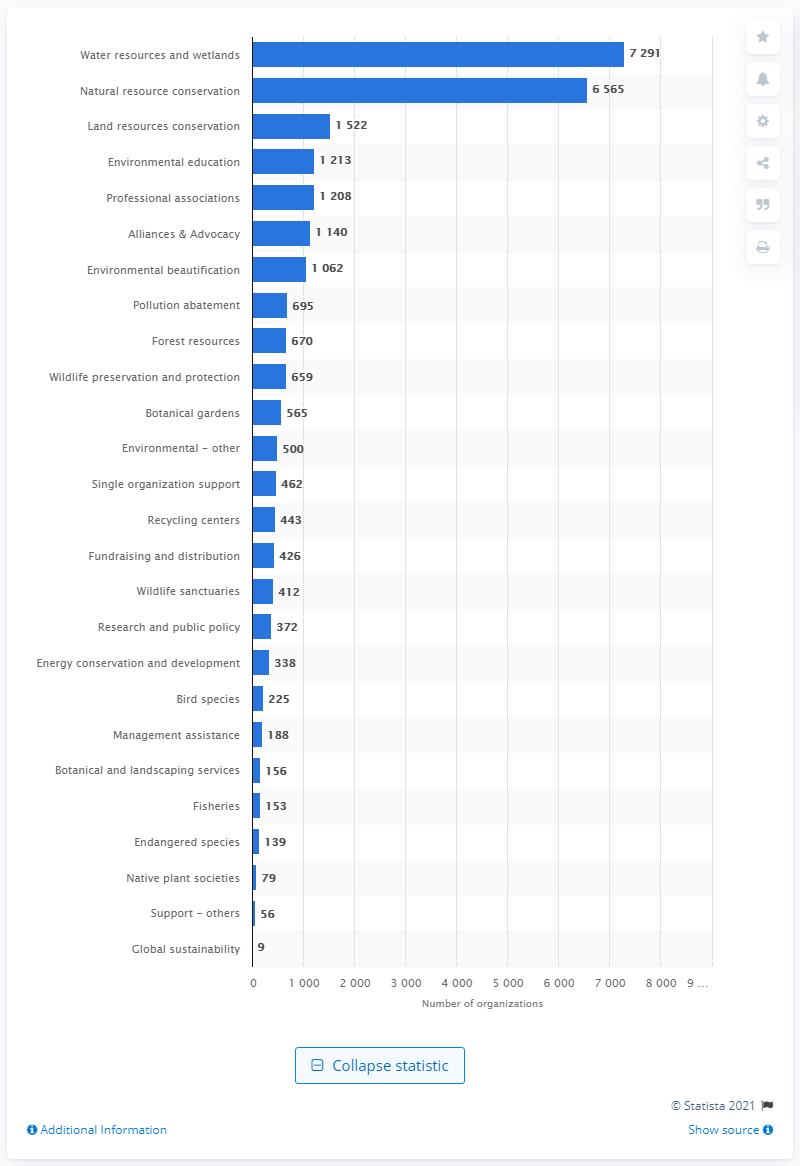Outline some significant characteristics in this image. There were 372 research and public policy oriented organizations among the registered environmental and conservation organizations in the United States in 2005. 